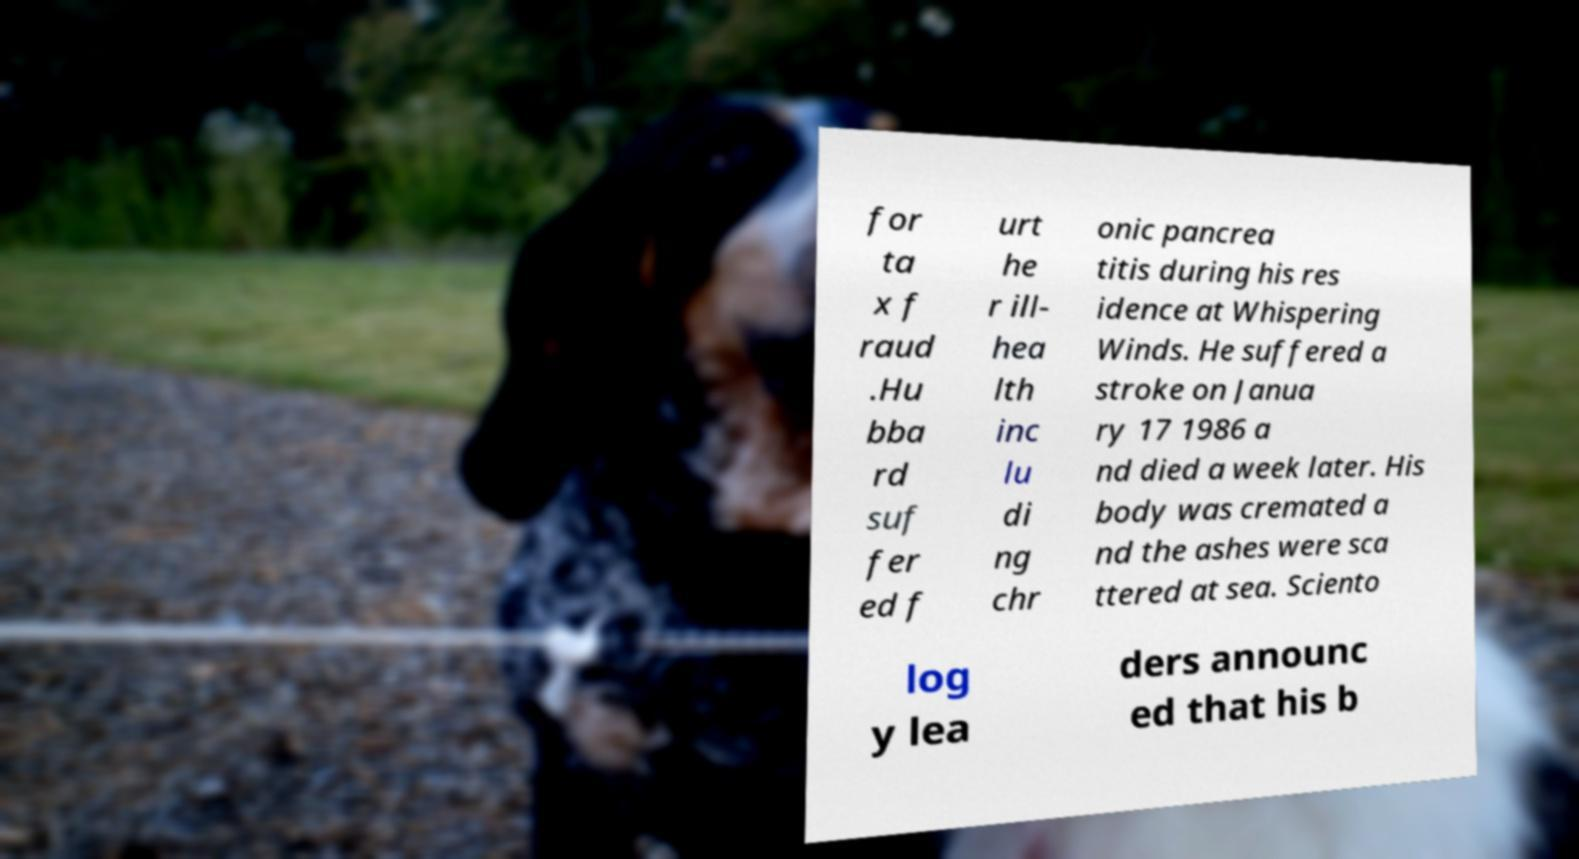Can you read and provide the text displayed in the image?This photo seems to have some interesting text. Can you extract and type it out for me? for ta x f raud .Hu bba rd suf fer ed f urt he r ill- hea lth inc lu di ng chr onic pancrea titis during his res idence at Whispering Winds. He suffered a stroke on Janua ry 17 1986 a nd died a week later. His body was cremated a nd the ashes were sca ttered at sea. Sciento log y lea ders announc ed that his b 